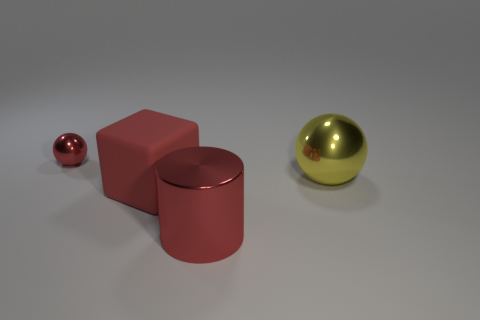There is a big cube that is the same color as the big shiny cylinder; what is it made of?
Make the answer very short. Rubber. Are there any big spheres left of the red metallic object that is right of the small red sphere?
Give a very brief answer. No. There is a ball that is on the left side of the matte object; is its color the same as the large object that is in front of the red matte thing?
Offer a very short reply. Yes. How many yellow objects have the same size as the red rubber object?
Make the answer very short. 1. Does the shiny object that is in front of the yellow thing have the same size as the large block?
Offer a very short reply. Yes. What is the shape of the yellow metallic thing?
Offer a terse response. Sphere. What is the size of the cylinder that is the same color as the matte thing?
Your response must be concise. Large. Do the thing to the right of the large red metallic cylinder and the cube have the same material?
Make the answer very short. No. Is there a object that has the same color as the large metal ball?
Ensure brevity in your answer.  No. Is the shape of the red shiny object behind the metal cylinder the same as the shiny thing right of the red cylinder?
Make the answer very short. Yes. 